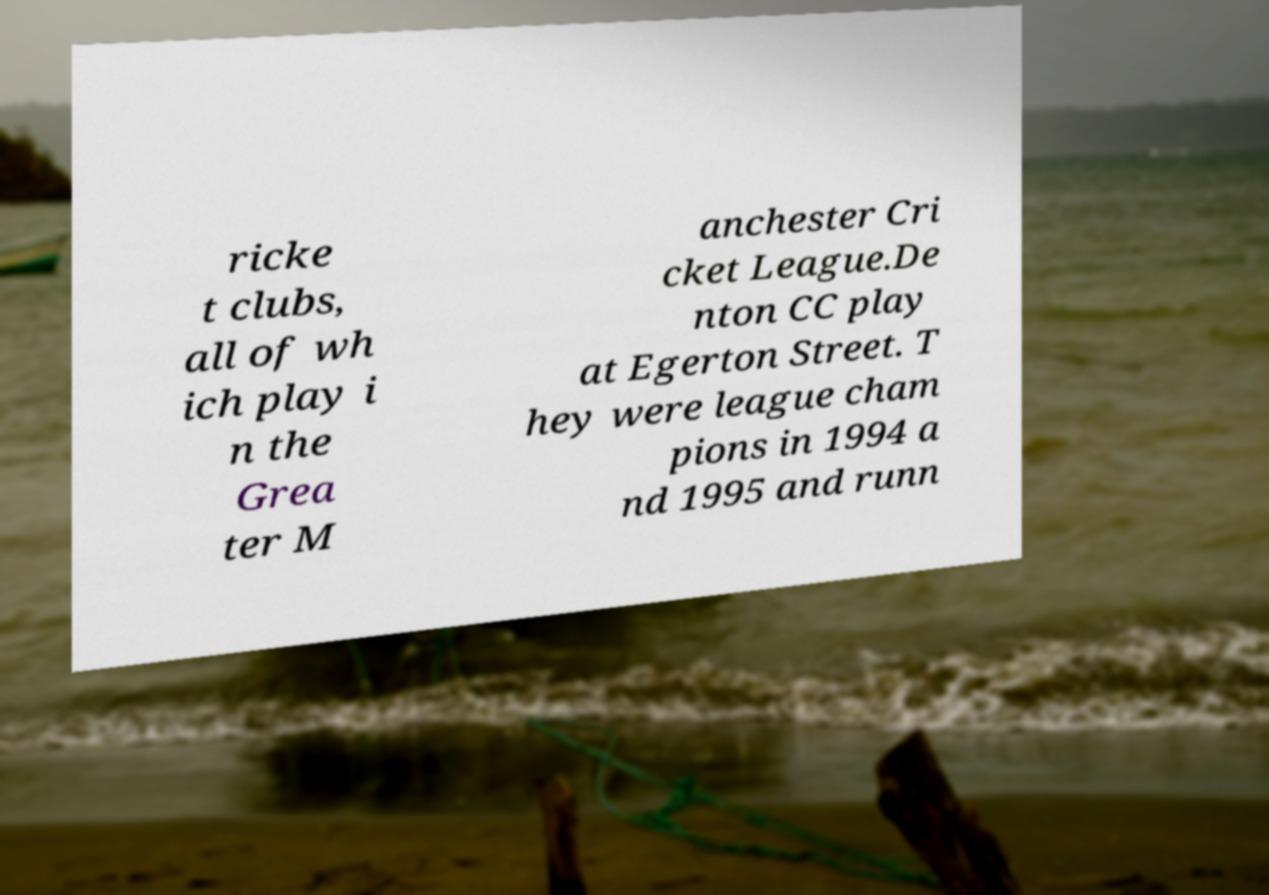Could you extract and type out the text from this image? ricke t clubs, all of wh ich play i n the Grea ter M anchester Cri cket League.De nton CC play at Egerton Street. T hey were league cham pions in 1994 a nd 1995 and runn 